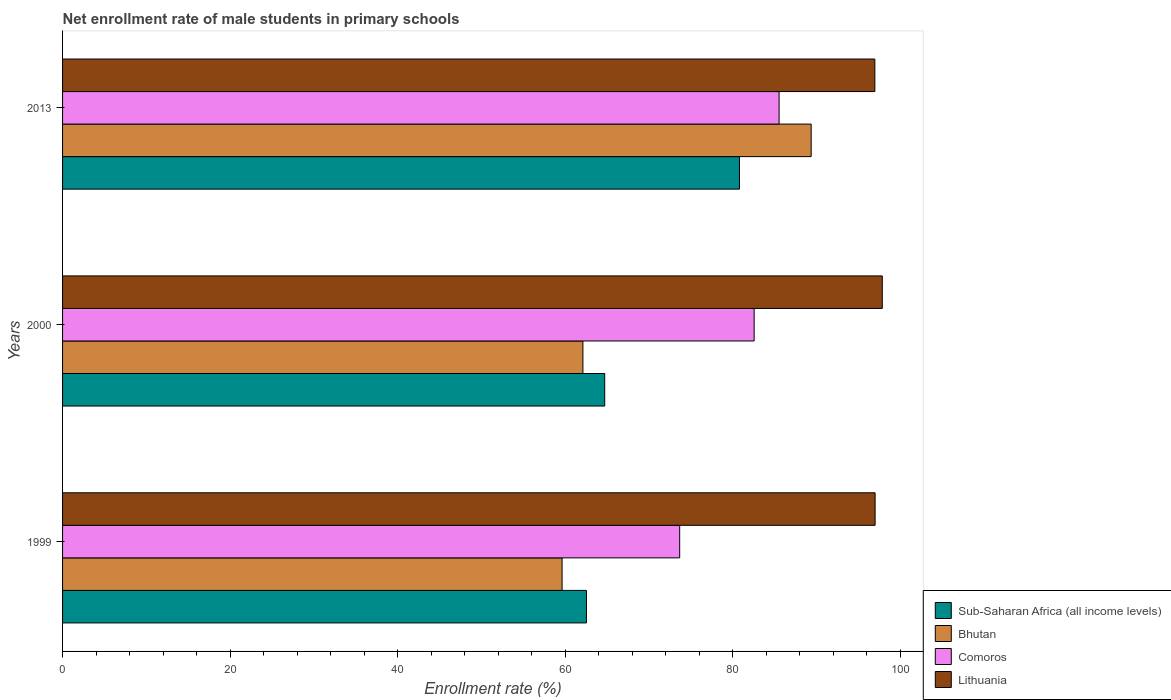How many different coloured bars are there?
Keep it short and to the point. 4. How many groups of bars are there?
Give a very brief answer. 3. Are the number of bars per tick equal to the number of legend labels?
Your response must be concise. Yes. Are the number of bars on each tick of the Y-axis equal?
Offer a terse response. Yes. How many bars are there on the 1st tick from the bottom?
Your response must be concise. 4. What is the net enrollment rate of male students in primary schools in Sub-Saharan Africa (all income levels) in 1999?
Give a very brief answer. 62.52. Across all years, what is the maximum net enrollment rate of male students in primary schools in Bhutan?
Provide a short and direct response. 89.34. Across all years, what is the minimum net enrollment rate of male students in primary schools in Sub-Saharan Africa (all income levels)?
Give a very brief answer. 62.52. In which year was the net enrollment rate of male students in primary schools in Comoros maximum?
Provide a succinct answer. 2013. What is the total net enrollment rate of male students in primary schools in Bhutan in the graph?
Your answer should be very brief. 211.05. What is the difference between the net enrollment rate of male students in primary schools in Lithuania in 1999 and that in 2013?
Your answer should be very brief. 0.03. What is the difference between the net enrollment rate of male students in primary schools in Lithuania in 2000 and the net enrollment rate of male students in primary schools in Sub-Saharan Africa (all income levels) in 2013?
Ensure brevity in your answer.  17.04. What is the average net enrollment rate of male students in primary schools in Lithuania per year?
Keep it short and to the point. 97.25. In the year 2000, what is the difference between the net enrollment rate of male students in primary schools in Sub-Saharan Africa (all income levels) and net enrollment rate of male students in primary schools in Lithuania?
Ensure brevity in your answer.  -33.12. What is the ratio of the net enrollment rate of male students in primary schools in Sub-Saharan Africa (all income levels) in 2000 to that in 2013?
Provide a short and direct response. 0.8. Is the net enrollment rate of male students in primary schools in Bhutan in 1999 less than that in 2013?
Give a very brief answer. Yes. Is the difference between the net enrollment rate of male students in primary schools in Sub-Saharan Africa (all income levels) in 2000 and 2013 greater than the difference between the net enrollment rate of male students in primary schools in Lithuania in 2000 and 2013?
Provide a short and direct response. No. What is the difference between the highest and the second highest net enrollment rate of male students in primary schools in Lithuania?
Offer a very short reply. 0.86. What is the difference between the highest and the lowest net enrollment rate of male students in primary schools in Lithuania?
Offer a very short reply. 0.89. In how many years, is the net enrollment rate of male students in primary schools in Comoros greater than the average net enrollment rate of male students in primary schools in Comoros taken over all years?
Give a very brief answer. 2. What does the 2nd bar from the top in 1999 represents?
Provide a short and direct response. Comoros. What does the 4th bar from the bottom in 1999 represents?
Your response must be concise. Lithuania. Is it the case that in every year, the sum of the net enrollment rate of male students in primary schools in Bhutan and net enrollment rate of male students in primary schools in Lithuania is greater than the net enrollment rate of male students in primary schools in Sub-Saharan Africa (all income levels)?
Provide a short and direct response. Yes. Are all the bars in the graph horizontal?
Your response must be concise. Yes. What is the difference between two consecutive major ticks on the X-axis?
Keep it short and to the point. 20. Are the values on the major ticks of X-axis written in scientific E-notation?
Your response must be concise. No. Where does the legend appear in the graph?
Make the answer very short. Bottom right. How are the legend labels stacked?
Keep it short and to the point. Vertical. What is the title of the graph?
Offer a terse response. Net enrollment rate of male students in primary schools. What is the label or title of the X-axis?
Your response must be concise. Enrollment rate (%). What is the label or title of the Y-axis?
Your answer should be compact. Years. What is the Enrollment rate (%) of Sub-Saharan Africa (all income levels) in 1999?
Ensure brevity in your answer.  62.52. What is the Enrollment rate (%) of Bhutan in 1999?
Your answer should be very brief. 59.61. What is the Enrollment rate (%) of Comoros in 1999?
Offer a terse response. 73.65. What is the Enrollment rate (%) of Lithuania in 1999?
Provide a short and direct response. 96.97. What is the Enrollment rate (%) of Sub-Saharan Africa (all income levels) in 2000?
Your answer should be very brief. 64.7. What is the Enrollment rate (%) in Bhutan in 2000?
Your answer should be compact. 62.1. What is the Enrollment rate (%) of Comoros in 2000?
Provide a short and direct response. 82.53. What is the Enrollment rate (%) of Lithuania in 2000?
Your answer should be very brief. 97.83. What is the Enrollment rate (%) of Sub-Saharan Africa (all income levels) in 2013?
Give a very brief answer. 80.78. What is the Enrollment rate (%) in Bhutan in 2013?
Make the answer very short. 89.34. What is the Enrollment rate (%) in Comoros in 2013?
Keep it short and to the point. 85.51. What is the Enrollment rate (%) of Lithuania in 2013?
Your answer should be very brief. 96.94. Across all years, what is the maximum Enrollment rate (%) in Sub-Saharan Africa (all income levels)?
Provide a succinct answer. 80.78. Across all years, what is the maximum Enrollment rate (%) in Bhutan?
Give a very brief answer. 89.34. Across all years, what is the maximum Enrollment rate (%) in Comoros?
Keep it short and to the point. 85.51. Across all years, what is the maximum Enrollment rate (%) of Lithuania?
Provide a succinct answer. 97.83. Across all years, what is the minimum Enrollment rate (%) in Sub-Saharan Africa (all income levels)?
Ensure brevity in your answer.  62.52. Across all years, what is the minimum Enrollment rate (%) in Bhutan?
Your response must be concise. 59.61. Across all years, what is the minimum Enrollment rate (%) of Comoros?
Your answer should be compact. 73.65. Across all years, what is the minimum Enrollment rate (%) in Lithuania?
Offer a terse response. 96.94. What is the total Enrollment rate (%) of Sub-Saharan Africa (all income levels) in the graph?
Your answer should be compact. 208.01. What is the total Enrollment rate (%) in Bhutan in the graph?
Offer a terse response. 211.05. What is the total Enrollment rate (%) of Comoros in the graph?
Offer a very short reply. 241.7. What is the total Enrollment rate (%) of Lithuania in the graph?
Keep it short and to the point. 291.74. What is the difference between the Enrollment rate (%) of Sub-Saharan Africa (all income levels) in 1999 and that in 2000?
Your response must be concise. -2.18. What is the difference between the Enrollment rate (%) in Bhutan in 1999 and that in 2000?
Provide a succinct answer. -2.48. What is the difference between the Enrollment rate (%) of Comoros in 1999 and that in 2000?
Your response must be concise. -8.89. What is the difference between the Enrollment rate (%) of Lithuania in 1999 and that in 2000?
Keep it short and to the point. -0.86. What is the difference between the Enrollment rate (%) in Sub-Saharan Africa (all income levels) in 1999 and that in 2013?
Your answer should be very brief. -18.26. What is the difference between the Enrollment rate (%) of Bhutan in 1999 and that in 2013?
Give a very brief answer. -29.72. What is the difference between the Enrollment rate (%) of Comoros in 1999 and that in 2013?
Offer a terse response. -11.86. What is the difference between the Enrollment rate (%) in Lithuania in 1999 and that in 2013?
Offer a terse response. 0.03. What is the difference between the Enrollment rate (%) of Sub-Saharan Africa (all income levels) in 2000 and that in 2013?
Offer a terse response. -16.08. What is the difference between the Enrollment rate (%) of Bhutan in 2000 and that in 2013?
Make the answer very short. -27.24. What is the difference between the Enrollment rate (%) in Comoros in 2000 and that in 2013?
Ensure brevity in your answer.  -2.98. What is the difference between the Enrollment rate (%) in Lithuania in 2000 and that in 2013?
Offer a very short reply. 0.89. What is the difference between the Enrollment rate (%) in Sub-Saharan Africa (all income levels) in 1999 and the Enrollment rate (%) in Bhutan in 2000?
Your response must be concise. 0.42. What is the difference between the Enrollment rate (%) of Sub-Saharan Africa (all income levels) in 1999 and the Enrollment rate (%) of Comoros in 2000?
Ensure brevity in your answer.  -20.01. What is the difference between the Enrollment rate (%) in Sub-Saharan Africa (all income levels) in 1999 and the Enrollment rate (%) in Lithuania in 2000?
Offer a very short reply. -35.31. What is the difference between the Enrollment rate (%) of Bhutan in 1999 and the Enrollment rate (%) of Comoros in 2000?
Make the answer very short. -22.92. What is the difference between the Enrollment rate (%) of Bhutan in 1999 and the Enrollment rate (%) of Lithuania in 2000?
Offer a terse response. -38.21. What is the difference between the Enrollment rate (%) of Comoros in 1999 and the Enrollment rate (%) of Lithuania in 2000?
Give a very brief answer. -24.18. What is the difference between the Enrollment rate (%) of Sub-Saharan Africa (all income levels) in 1999 and the Enrollment rate (%) of Bhutan in 2013?
Offer a terse response. -26.82. What is the difference between the Enrollment rate (%) of Sub-Saharan Africa (all income levels) in 1999 and the Enrollment rate (%) of Comoros in 2013?
Ensure brevity in your answer.  -22.99. What is the difference between the Enrollment rate (%) in Sub-Saharan Africa (all income levels) in 1999 and the Enrollment rate (%) in Lithuania in 2013?
Provide a short and direct response. -34.42. What is the difference between the Enrollment rate (%) in Bhutan in 1999 and the Enrollment rate (%) in Comoros in 2013?
Your answer should be compact. -25.9. What is the difference between the Enrollment rate (%) in Bhutan in 1999 and the Enrollment rate (%) in Lithuania in 2013?
Offer a very short reply. -37.32. What is the difference between the Enrollment rate (%) in Comoros in 1999 and the Enrollment rate (%) in Lithuania in 2013?
Keep it short and to the point. -23.29. What is the difference between the Enrollment rate (%) of Sub-Saharan Africa (all income levels) in 2000 and the Enrollment rate (%) of Bhutan in 2013?
Keep it short and to the point. -24.64. What is the difference between the Enrollment rate (%) in Sub-Saharan Africa (all income levels) in 2000 and the Enrollment rate (%) in Comoros in 2013?
Keep it short and to the point. -20.81. What is the difference between the Enrollment rate (%) in Sub-Saharan Africa (all income levels) in 2000 and the Enrollment rate (%) in Lithuania in 2013?
Keep it short and to the point. -32.24. What is the difference between the Enrollment rate (%) in Bhutan in 2000 and the Enrollment rate (%) in Comoros in 2013?
Your answer should be compact. -23.41. What is the difference between the Enrollment rate (%) in Bhutan in 2000 and the Enrollment rate (%) in Lithuania in 2013?
Provide a short and direct response. -34.84. What is the difference between the Enrollment rate (%) in Comoros in 2000 and the Enrollment rate (%) in Lithuania in 2013?
Your answer should be very brief. -14.4. What is the average Enrollment rate (%) of Sub-Saharan Africa (all income levels) per year?
Offer a terse response. 69.34. What is the average Enrollment rate (%) in Bhutan per year?
Provide a succinct answer. 70.35. What is the average Enrollment rate (%) in Comoros per year?
Offer a very short reply. 80.57. What is the average Enrollment rate (%) in Lithuania per year?
Provide a short and direct response. 97.25. In the year 1999, what is the difference between the Enrollment rate (%) in Sub-Saharan Africa (all income levels) and Enrollment rate (%) in Bhutan?
Keep it short and to the point. 2.91. In the year 1999, what is the difference between the Enrollment rate (%) of Sub-Saharan Africa (all income levels) and Enrollment rate (%) of Comoros?
Keep it short and to the point. -11.13. In the year 1999, what is the difference between the Enrollment rate (%) of Sub-Saharan Africa (all income levels) and Enrollment rate (%) of Lithuania?
Keep it short and to the point. -34.45. In the year 1999, what is the difference between the Enrollment rate (%) of Bhutan and Enrollment rate (%) of Comoros?
Offer a very short reply. -14.03. In the year 1999, what is the difference between the Enrollment rate (%) in Bhutan and Enrollment rate (%) in Lithuania?
Your response must be concise. -37.36. In the year 1999, what is the difference between the Enrollment rate (%) of Comoros and Enrollment rate (%) of Lithuania?
Ensure brevity in your answer.  -23.32. In the year 2000, what is the difference between the Enrollment rate (%) of Sub-Saharan Africa (all income levels) and Enrollment rate (%) of Bhutan?
Your answer should be compact. 2.6. In the year 2000, what is the difference between the Enrollment rate (%) of Sub-Saharan Africa (all income levels) and Enrollment rate (%) of Comoros?
Provide a succinct answer. -17.83. In the year 2000, what is the difference between the Enrollment rate (%) of Sub-Saharan Africa (all income levels) and Enrollment rate (%) of Lithuania?
Your answer should be compact. -33.12. In the year 2000, what is the difference between the Enrollment rate (%) of Bhutan and Enrollment rate (%) of Comoros?
Offer a very short reply. -20.44. In the year 2000, what is the difference between the Enrollment rate (%) in Bhutan and Enrollment rate (%) in Lithuania?
Offer a terse response. -35.73. In the year 2000, what is the difference between the Enrollment rate (%) in Comoros and Enrollment rate (%) in Lithuania?
Offer a very short reply. -15.29. In the year 2013, what is the difference between the Enrollment rate (%) in Sub-Saharan Africa (all income levels) and Enrollment rate (%) in Bhutan?
Provide a short and direct response. -8.56. In the year 2013, what is the difference between the Enrollment rate (%) of Sub-Saharan Africa (all income levels) and Enrollment rate (%) of Comoros?
Keep it short and to the point. -4.73. In the year 2013, what is the difference between the Enrollment rate (%) of Sub-Saharan Africa (all income levels) and Enrollment rate (%) of Lithuania?
Give a very brief answer. -16.16. In the year 2013, what is the difference between the Enrollment rate (%) of Bhutan and Enrollment rate (%) of Comoros?
Keep it short and to the point. 3.83. In the year 2013, what is the difference between the Enrollment rate (%) in Bhutan and Enrollment rate (%) in Lithuania?
Provide a short and direct response. -7.6. In the year 2013, what is the difference between the Enrollment rate (%) in Comoros and Enrollment rate (%) in Lithuania?
Your answer should be very brief. -11.43. What is the ratio of the Enrollment rate (%) in Sub-Saharan Africa (all income levels) in 1999 to that in 2000?
Your answer should be compact. 0.97. What is the ratio of the Enrollment rate (%) in Bhutan in 1999 to that in 2000?
Provide a succinct answer. 0.96. What is the ratio of the Enrollment rate (%) of Comoros in 1999 to that in 2000?
Your response must be concise. 0.89. What is the ratio of the Enrollment rate (%) of Lithuania in 1999 to that in 2000?
Provide a succinct answer. 0.99. What is the ratio of the Enrollment rate (%) of Sub-Saharan Africa (all income levels) in 1999 to that in 2013?
Keep it short and to the point. 0.77. What is the ratio of the Enrollment rate (%) in Bhutan in 1999 to that in 2013?
Offer a very short reply. 0.67. What is the ratio of the Enrollment rate (%) in Comoros in 1999 to that in 2013?
Your response must be concise. 0.86. What is the ratio of the Enrollment rate (%) in Lithuania in 1999 to that in 2013?
Your response must be concise. 1. What is the ratio of the Enrollment rate (%) in Sub-Saharan Africa (all income levels) in 2000 to that in 2013?
Your answer should be very brief. 0.8. What is the ratio of the Enrollment rate (%) of Bhutan in 2000 to that in 2013?
Provide a succinct answer. 0.7. What is the ratio of the Enrollment rate (%) in Comoros in 2000 to that in 2013?
Your answer should be compact. 0.97. What is the ratio of the Enrollment rate (%) in Lithuania in 2000 to that in 2013?
Your answer should be compact. 1.01. What is the difference between the highest and the second highest Enrollment rate (%) in Sub-Saharan Africa (all income levels)?
Ensure brevity in your answer.  16.08. What is the difference between the highest and the second highest Enrollment rate (%) in Bhutan?
Your response must be concise. 27.24. What is the difference between the highest and the second highest Enrollment rate (%) in Comoros?
Your response must be concise. 2.98. What is the difference between the highest and the second highest Enrollment rate (%) in Lithuania?
Keep it short and to the point. 0.86. What is the difference between the highest and the lowest Enrollment rate (%) of Sub-Saharan Africa (all income levels)?
Keep it short and to the point. 18.26. What is the difference between the highest and the lowest Enrollment rate (%) of Bhutan?
Your answer should be very brief. 29.72. What is the difference between the highest and the lowest Enrollment rate (%) in Comoros?
Provide a succinct answer. 11.86. What is the difference between the highest and the lowest Enrollment rate (%) of Lithuania?
Offer a very short reply. 0.89. 